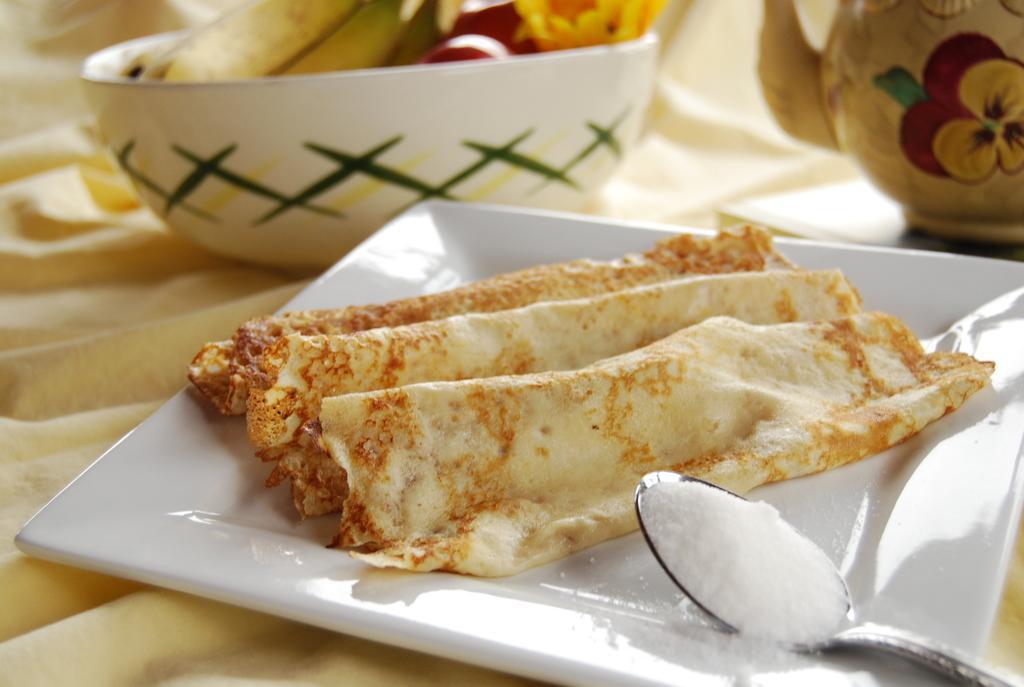Please provide a concise description of this image. In this picture I can see food items on the plate and in a bowl, there is a spoon with powder, this is looking like a teapot on the cloth. 